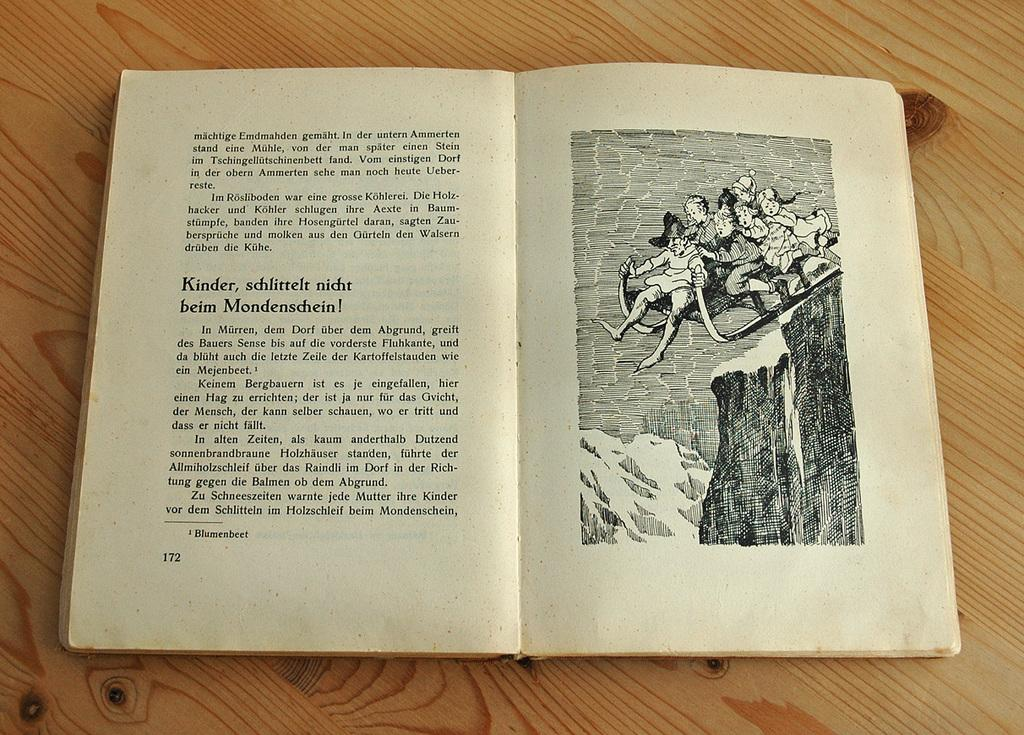<image>
Give a short and clear explanation of the subsequent image. some people in a photo with words in a different language next to them 